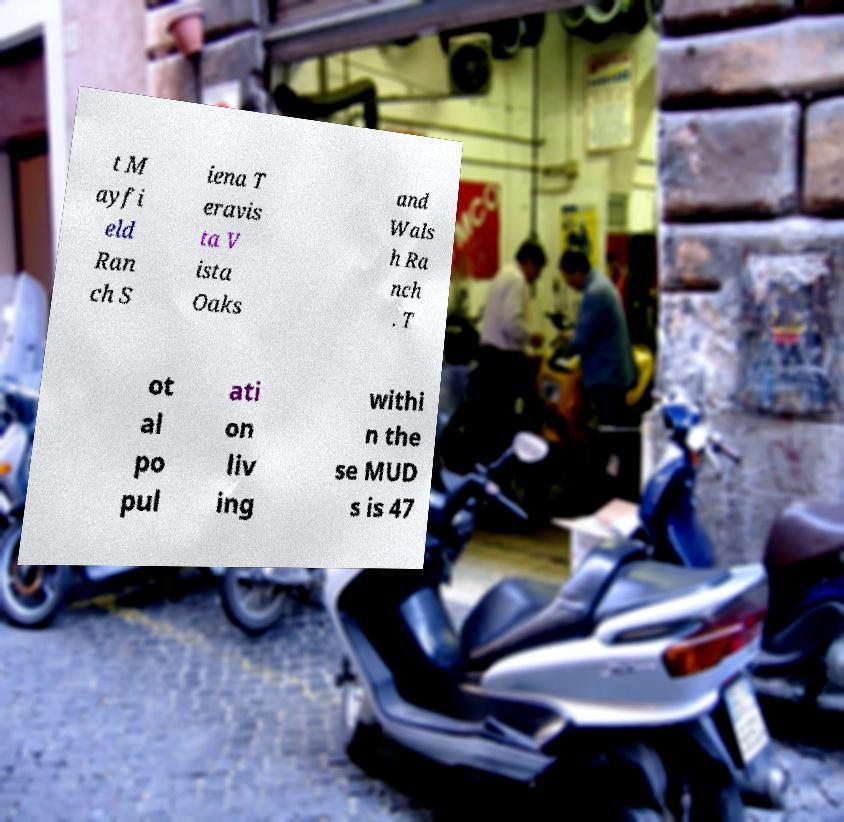For documentation purposes, I need the text within this image transcribed. Could you provide that? t M ayfi eld Ran ch S iena T eravis ta V ista Oaks and Wals h Ra nch . T ot al po pul ati on liv ing withi n the se MUD s is 47 